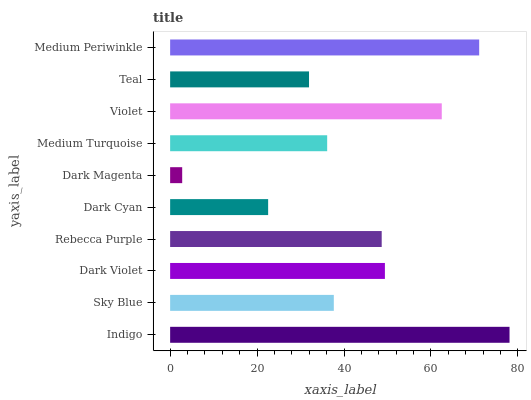Is Dark Magenta the minimum?
Answer yes or no. Yes. Is Indigo the maximum?
Answer yes or no. Yes. Is Sky Blue the minimum?
Answer yes or no. No. Is Sky Blue the maximum?
Answer yes or no. No. Is Indigo greater than Sky Blue?
Answer yes or no. Yes. Is Sky Blue less than Indigo?
Answer yes or no. Yes. Is Sky Blue greater than Indigo?
Answer yes or no. No. Is Indigo less than Sky Blue?
Answer yes or no. No. Is Rebecca Purple the high median?
Answer yes or no. Yes. Is Sky Blue the low median?
Answer yes or no. Yes. Is Violet the high median?
Answer yes or no. No. Is Teal the low median?
Answer yes or no. No. 